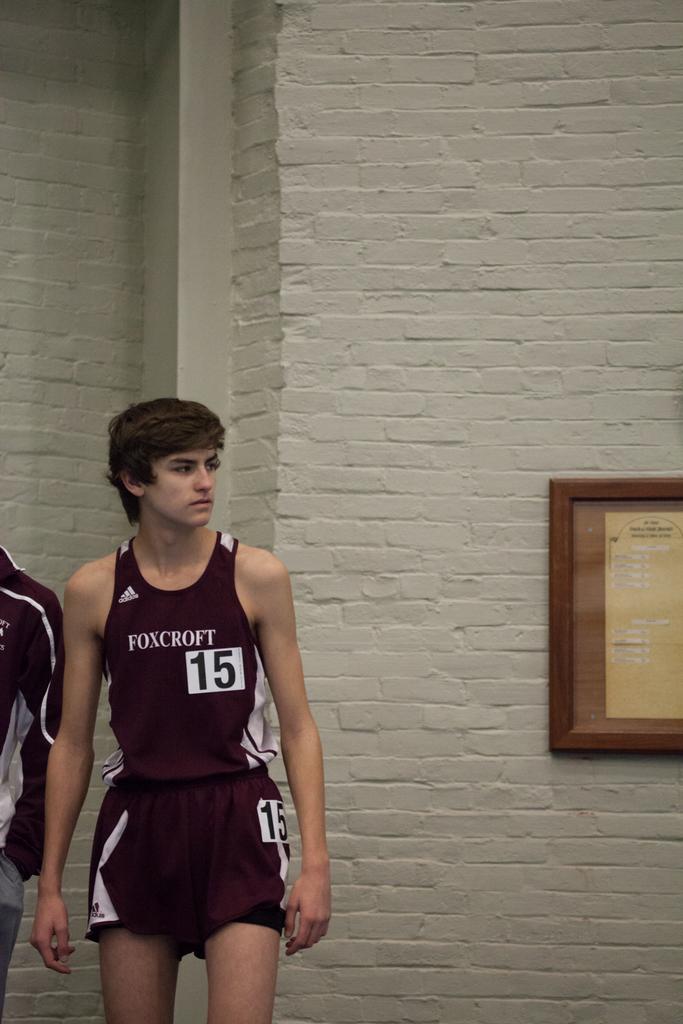What is the name of team the person play for?
Your response must be concise. Foxcroft. What number is the boy?
Provide a succinct answer. 15. 